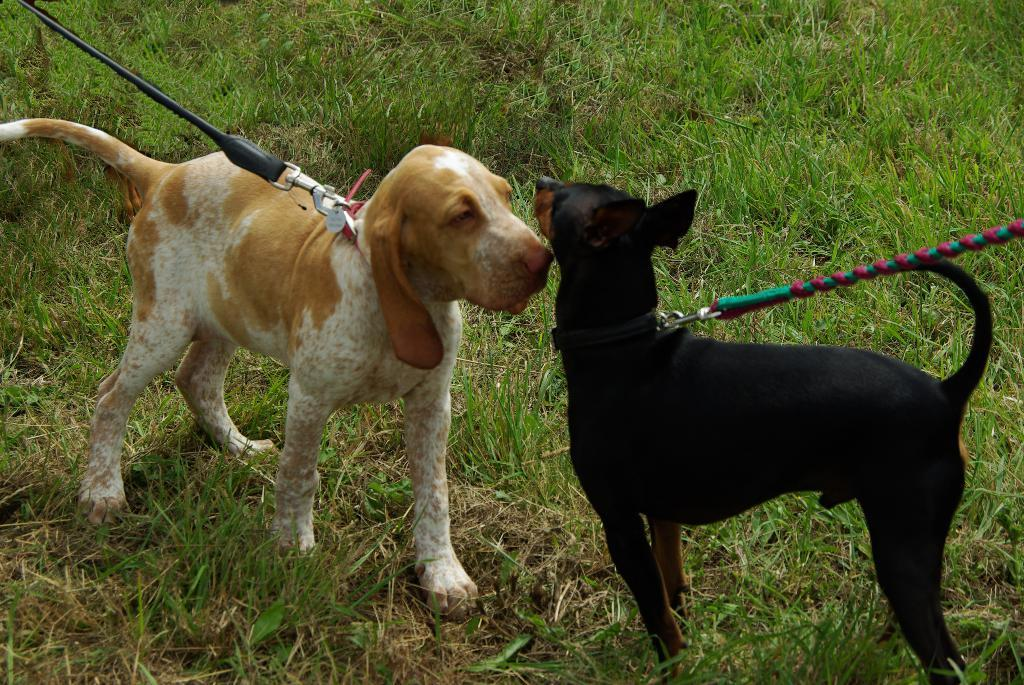How many dogs are in the image? There are two dogs in the image. What is the surface the dogs are standing on? The dogs are standing on the ground. What type of vegetation is present on the ground? There is grass on the ground. What accessories are the dogs wearing in the image? The dogs have belts around their necks, and there are ropes attached to the belts. What type of sleet can be seen falling in the image? There is no sleet present in the image; it is a clear day with grass on the ground. 